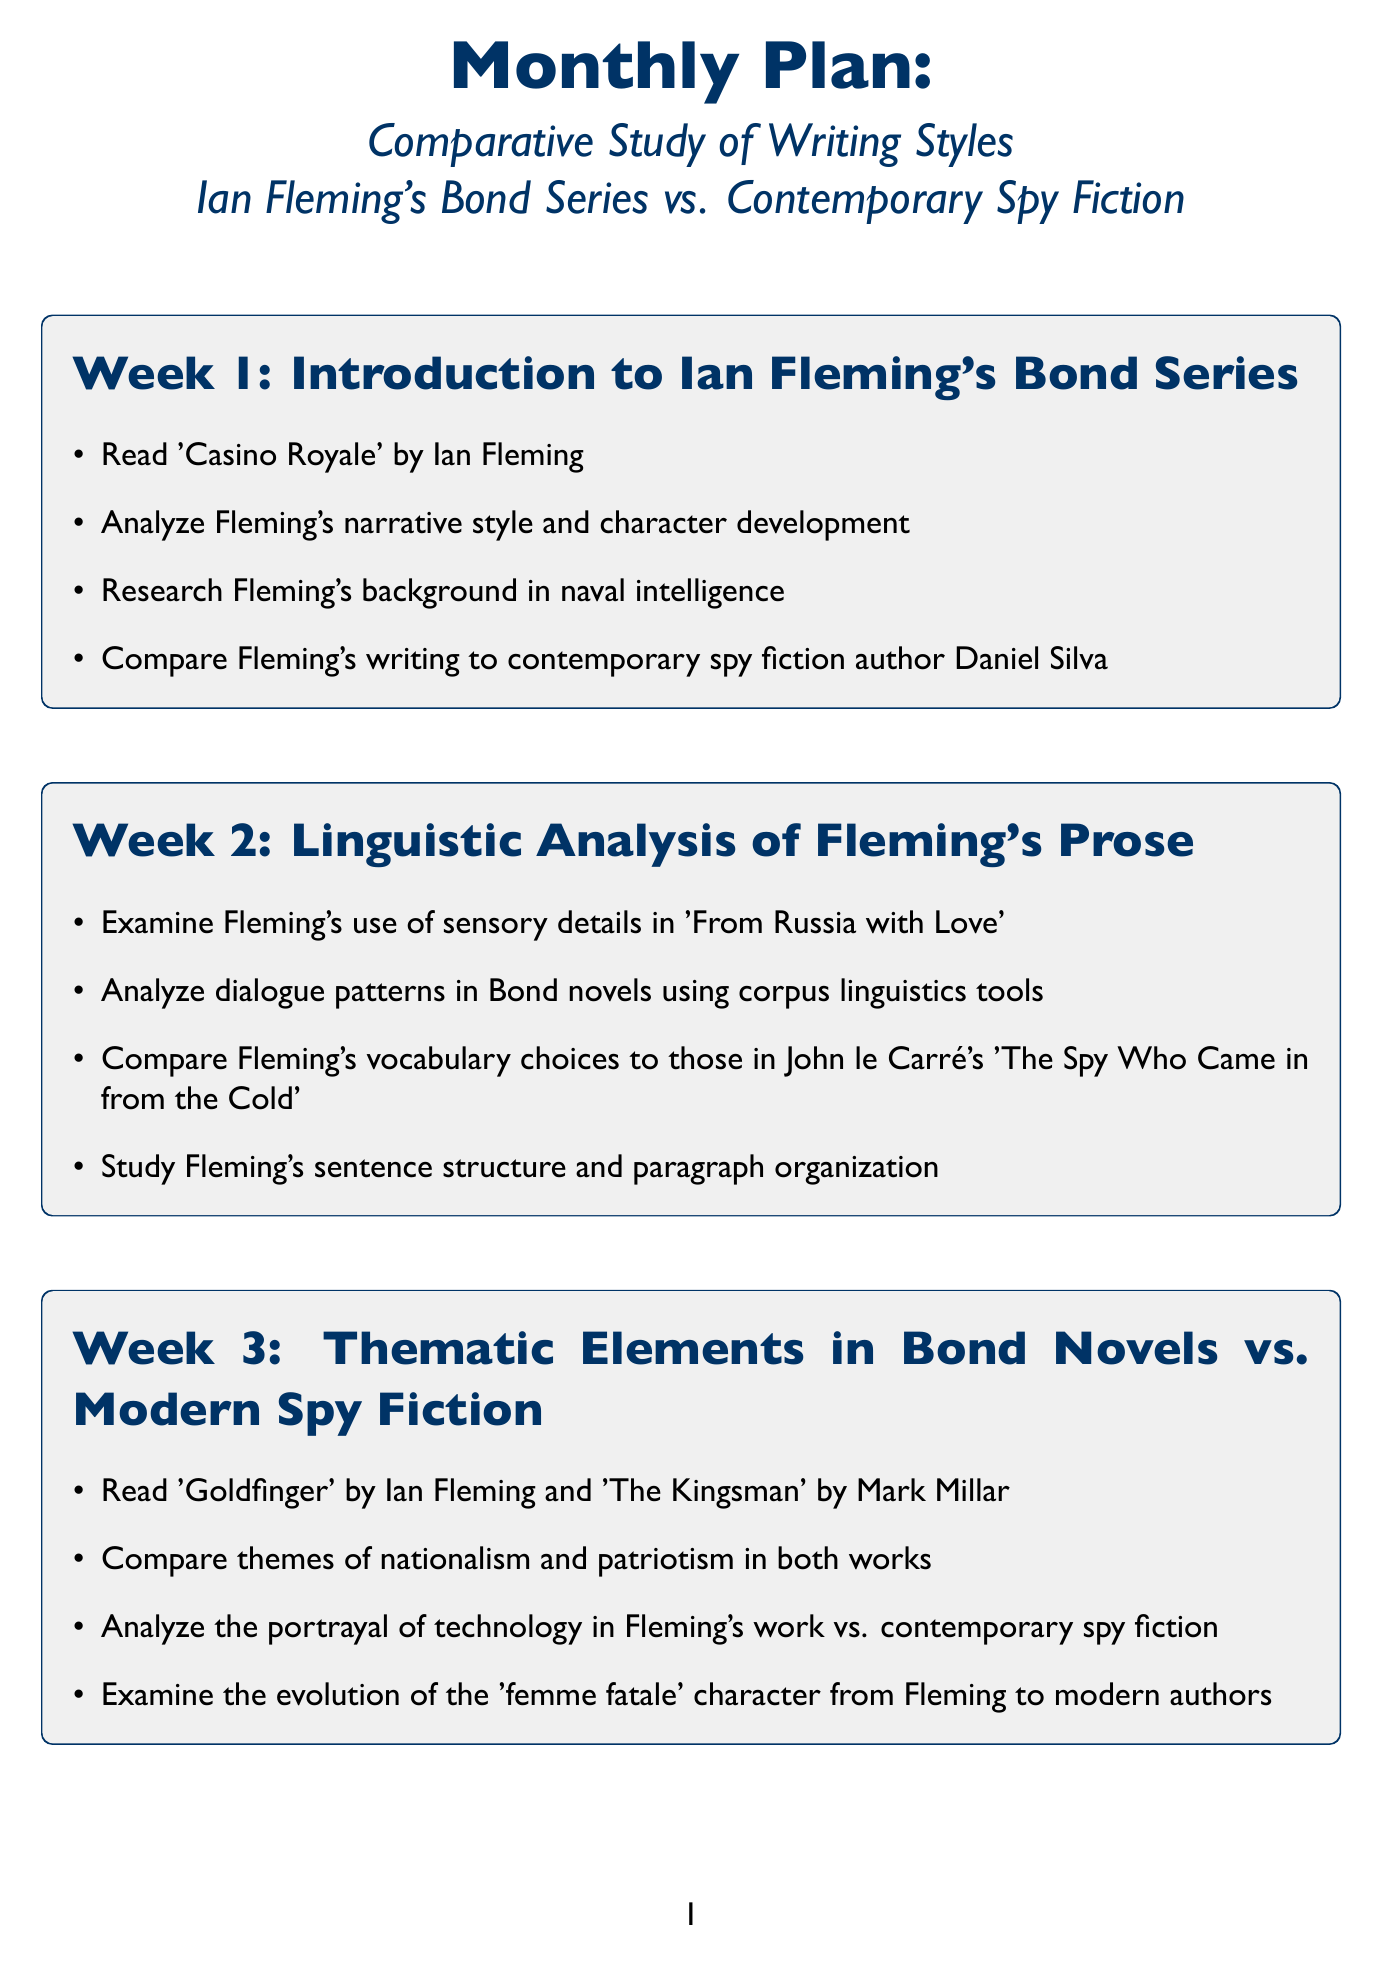What is the focus of Week 1? The focus of Week 1 is stated explicitly in the document as "Introduction to Ian Fleming's Bond series."
Answer: Introduction to Ian Fleming's Bond series Which novel is read in Week 5? The document lists 'Thunderball' by Ian Fleming as one of the readings for Week 5.
Answer: Thunderball How many weeks are in the monthly plan? The document outlines a plan that spans a total of 8 weeks.
Answer: 8 Who is compared to Ian Fleming in Week 1's activities? The document specifies that Fleming's writing is compared to contemporary spy fiction author Daniel Silva.
Answer: Daniel Silva In which week is the analysis of the 'femme fatale' character conducted? The analysis of the 'femme fatale' character is mentioned in connection with Week 3's activities.
Answer: Week 3 What is the primary activity type in Week 2? Week 2 primarily involves analyzing linguistic aspects of Ian Fleming's prose.
Answer: Analyzing linguistic aspects Which author's novel is compared to Fleming's 'From Russia with Love' in Week 2? The document indicates that John le Carré's 'The Spy Who Came in from the Cold' is the work compared to Fleming's.
Answer: John le Carré What theme is examined in Week 3? The document states that Week 3 includes the comparison of themes of nationalism and patriotism.
Answer: Nationalism and patriotism Which prominent historical context is researched in Week 6? The document notes that the Cold War context of Fleming's novels is researched in Week 6.
Answer: Cold War 